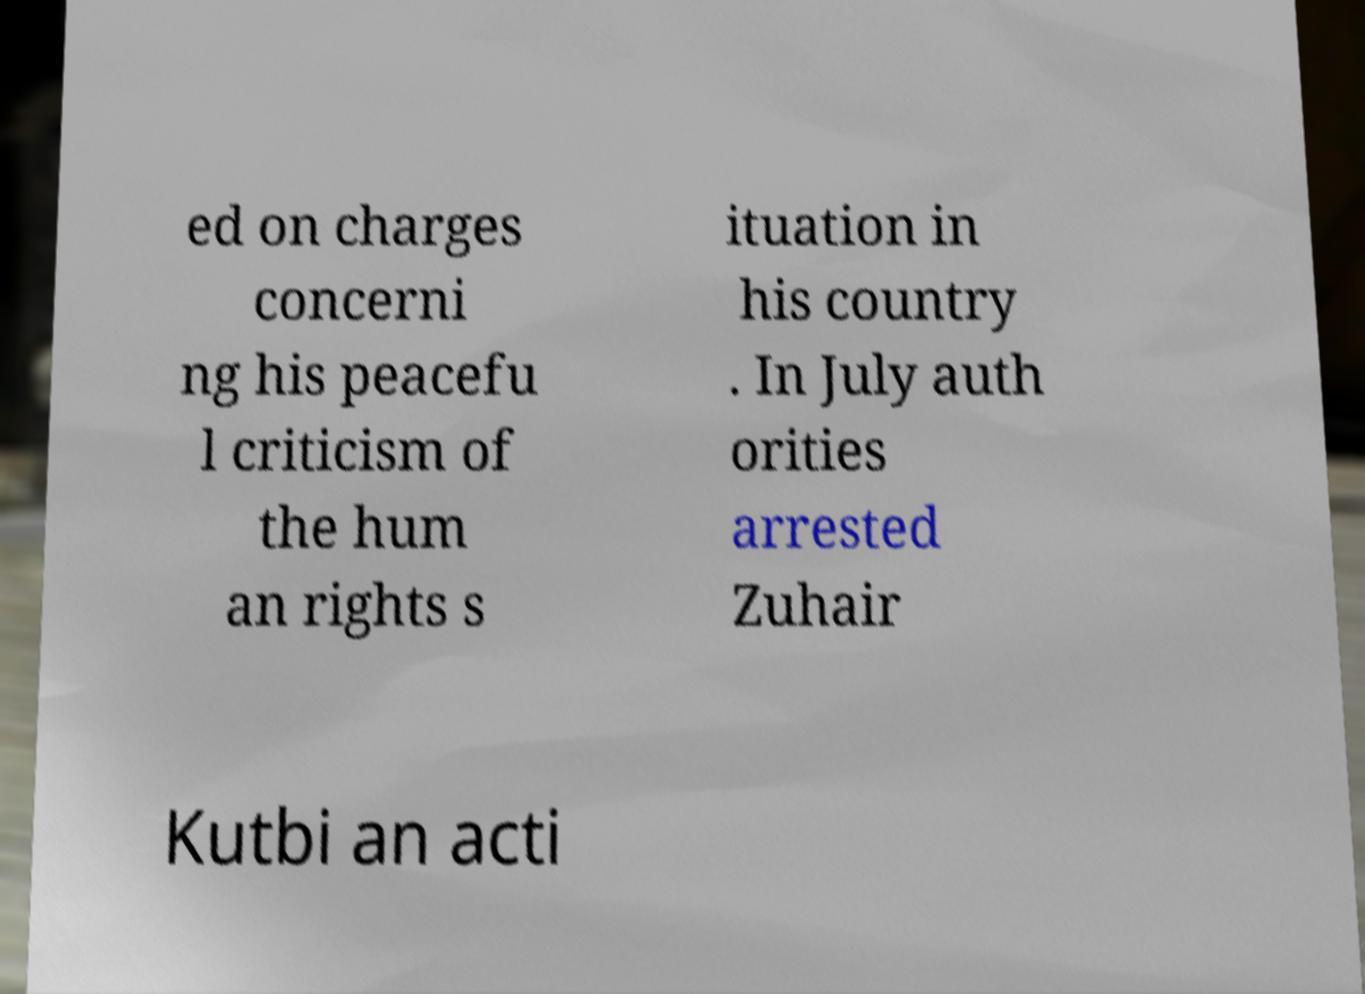For documentation purposes, I need the text within this image transcribed. Could you provide that? ed on charges concerni ng his peacefu l criticism of the hum an rights s ituation in his country . In July auth orities arrested Zuhair Kutbi an acti 